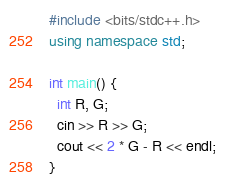<code> <loc_0><loc_0><loc_500><loc_500><_C++_>#include <bits/stdc++.h>
using namespace std;

int main() {
  int R, G;  
  cin >> R >> G;
  cout << 2 * G - R << endl;
}</code> 